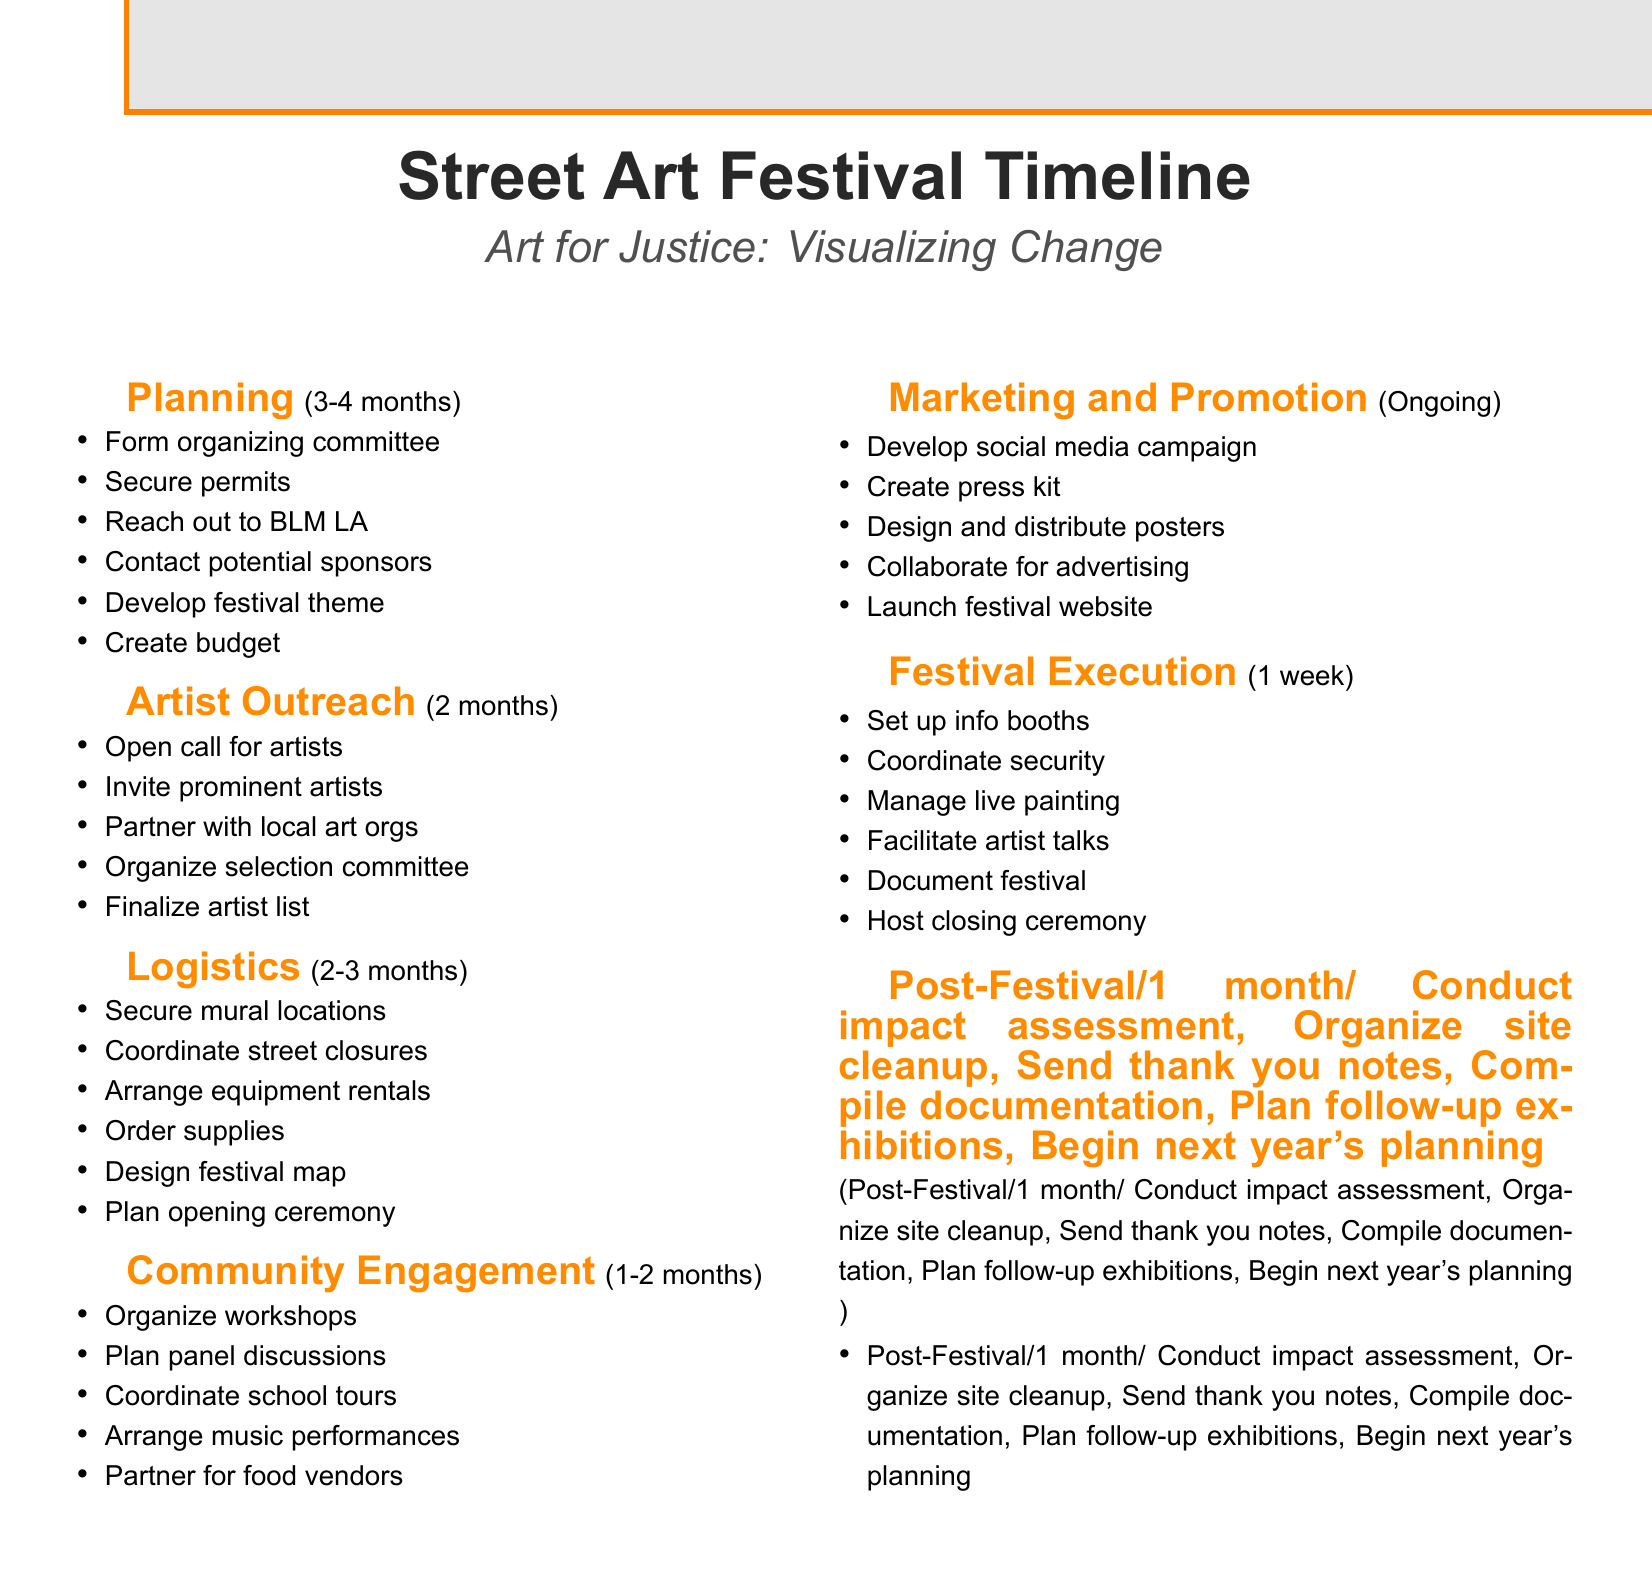What is the duration of the Planning phase? The duration of the Planning phase is specified in the document as 3-4 months.
Answer: 3-4 months How many months is allocated for Artist Outreach? The document states that the Artist Outreach phase has a duration of 2 months.
Answer: 2 months Which organization is reached out to for collaboration? The document mentions reaching out to Black Lives Matter LA for collaboration during the Planning phase.
Answer: Black Lives Matter LA What is the festival theme? The festival theme is stated as 'Art for Justice: Visualizing Change' in the Planning phase.
Answer: Art for Justice: Visualizing Change How long is the Festival Execution phase? The duration for the Festival Execution phase is mentioned in the document as 1 week.
Answer: 1 week What community organization is involved in organizing workshops? The document indicates that the Youth Justice Coalition is involved in organizing workshops during the Community Engagement phase.
Answer: Youth Justice Coalition Who is responsible for impact assessment post-festival? The USC Annenberg School for Communication and Journalism is responsible for conducting impact assessment post-festival, as noted in the Post-Festival phase.
Answer: USC Annenberg School for Communication and Journalism What is one marketing activity mentioned in the document? The document mentions developing a social media campaign as one of the marketing activities during the ongoing Marketing and Promotion phase.
Answer: Develop social media campaign 